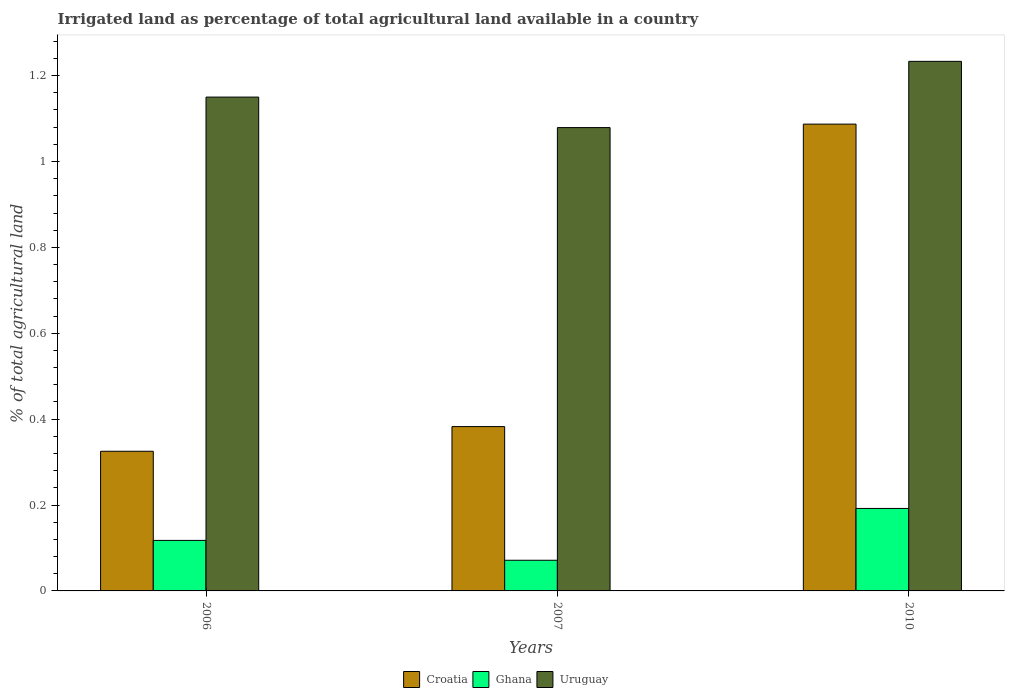How many groups of bars are there?
Offer a terse response. 3. Are the number of bars on each tick of the X-axis equal?
Offer a terse response. Yes. How many bars are there on the 3rd tick from the left?
Provide a succinct answer. 3. How many bars are there on the 2nd tick from the right?
Provide a succinct answer. 3. In how many cases, is the number of bars for a given year not equal to the number of legend labels?
Provide a short and direct response. 0. What is the percentage of irrigated land in Uruguay in 2006?
Provide a succinct answer. 1.15. Across all years, what is the maximum percentage of irrigated land in Croatia?
Your answer should be very brief. 1.09. Across all years, what is the minimum percentage of irrigated land in Uruguay?
Give a very brief answer. 1.08. What is the total percentage of irrigated land in Croatia in the graph?
Give a very brief answer. 1.8. What is the difference between the percentage of irrigated land in Ghana in 2006 and that in 2010?
Offer a terse response. -0.07. What is the difference between the percentage of irrigated land in Uruguay in 2007 and the percentage of irrigated land in Croatia in 2006?
Provide a short and direct response. 0.75. What is the average percentage of irrigated land in Ghana per year?
Your answer should be compact. 0.13. In the year 2007, what is the difference between the percentage of irrigated land in Ghana and percentage of irrigated land in Uruguay?
Your response must be concise. -1.01. In how many years, is the percentage of irrigated land in Uruguay greater than 0.24000000000000002 %?
Offer a very short reply. 3. What is the ratio of the percentage of irrigated land in Croatia in 2006 to that in 2010?
Provide a succinct answer. 0.3. Is the difference between the percentage of irrigated land in Ghana in 2006 and 2010 greater than the difference between the percentage of irrigated land in Uruguay in 2006 and 2010?
Your response must be concise. Yes. What is the difference between the highest and the second highest percentage of irrigated land in Uruguay?
Offer a terse response. 0.08. What is the difference between the highest and the lowest percentage of irrigated land in Uruguay?
Your answer should be compact. 0.15. In how many years, is the percentage of irrigated land in Ghana greater than the average percentage of irrigated land in Ghana taken over all years?
Your answer should be compact. 1. What does the 3rd bar from the left in 2006 represents?
Provide a succinct answer. Uruguay. What does the 1st bar from the right in 2010 represents?
Give a very brief answer. Uruguay. How many bars are there?
Keep it short and to the point. 9. Are all the bars in the graph horizontal?
Provide a short and direct response. No. Does the graph contain any zero values?
Make the answer very short. No. Does the graph contain grids?
Your answer should be very brief. No. How many legend labels are there?
Your answer should be very brief. 3. How are the legend labels stacked?
Your response must be concise. Horizontal. What is the title of the graph?
Provide a short and direct response. Irrigated land as percentage of total agricultural land available in a country. What is the label or title of the Y-axis?
Your answer should be compact. % of total agricultural land. What is the % of total agricultural land in Croatia in 2006?
Keep it short and to the point. 0.33. What is the % of total agricultural land of Ghana in 2006?
Give a very brief answer. 0.12. What is the % of total agricultural land in Uruguay in 2006?
Your answer should be very brief. 1.15. What is the % of total agricultural land of Croatia in 2007?
Provide a succinct answer. 0.38. What is the % of total agricultural land in Ghana in 2007?
Your answer should be very brief. 0.07. What is the % of total agricultural land in Uruguay in 2007?
Your answer should be compact. 1.08. What is the % of total agricultural land of Croatia in 2010?
Your response must be concise. 1.09. What is the % of total agricultural land in Ghana in 2010?
Ensure brevity in your answer.  0.19. What is the % of total agricultural land of Uruguay in 2010?
Your answer should be compact. 1.23. Across all years, what is the maximum % of total agricultural land of Croatia?
Provide a succinct answer. 1.09. Across all years, what is the maximum % of total agricultural land of Ghana?
Offer a terse response. 0.19. Across all years, what is the maximum % of total agricultural land of Uruguay?
Keep it short and to the point. 1.23. Across all years, what is the minimum % of total agricultural land in Croatia?
Offer a terse response. 0.33. Across all years, what is the minimum % of total agricultural land of Ghana?
Provide a short and direct response. 0.07. Across all years, what is the minimum % of total agricultural land in Uruguay?
Offer a terse response. 1.08. What is the total % of total agricultural land in Croatia in the graph?
Provide a short and direct response. 1.79. What is the total % of total agricultural land in Ghana in the graph?
Keep it short and to the point. 0.38. What is the total % of total agricultural land in Uruguay in the graph?
Keep it short and to the point. 3.46. What is the difference between the % of total agricultural land in Croatia in 2006 and that in 2007?
Your response must be concise. -0.06. What is the difference between the % of total agricultural land in Ghana in 2006 and that in 2007?
Keep it short and to the point. 0.05. What is the difference between the % of total agricultural land of Uruguay in 2006 and that in 2007?
Your answer should be very brief. 0.07. What is the difference between the % of total agricultural land of Croatia in 2006 and that in 2010?
Ensure brevity in your answer.  -0.76. What is the difference between the % of total agricultural land in Ghana in 2006 and that in 2010?
Your answer should be very brief. -0.07. What is the difference between the % of total agricultural land in Uruguay in 2006 and that in 2010?
Ensure brevity in your answer.  -0.08. What is the difference between the % of total agricultural land in Croatia in 2007 and that in 2010?
Offer a very short reply. -0.7. What is the difference between the % of total agricultural land in Ghana in 2007 and that in 2010?
Ensure brevity in your answer.  -0.12. What is the difference between the % of total agricultural land in Uruguay in 2007 and that in 2010?
Offer a terse response. -0.15. What is the difference between the % of total agricultural land of Croatia in 2006 and the % of total agricultural land of Ghana in 2007?
Provide a short and direct response. 0.25. What is the difference between the % of total agricultural land in Croatia in 2006 and the % of total agricultural land in Uruguay in 2007?
Offer a terse response. -0.75. What is the difference between the % of total agricultural land in Ghana in 2006 and the % of total agricultural land in Uruguay in 2007?
Make the answer very short. -0.96. What is the difference between the % of total agricultural land of Croatia in 2006 and the % of total agricultural land of Ghana in 2010?
Provide a short and direct response. 0.13. What is the difference between the % of total agricultural land of Croatia in 2006 and the % of total agricultural land of Uruguay in 2010?
Keep it short and to the point. -0.91. What is the difference between the % of total agricultural land of Ghana in 2006 and the % of total agricultural land of Uruguay in 2010?
Keep it short and to the point. -1.12. What is the difference between the % of total agricultural land in Croatia in 2007 and the % of total agricultural land in Ghana in 2010?
Your response must be concise. 0.19. What is the difference between the % of total agricultural land of Croatia in 2007 and the % of total agricultural land of Uruguay in 2010?
Ensure brevity in your answer.  -0.85. What is the difference between the % of total agricultural land of Ghana in 2007 and the % of total agricultural land of Uruguay in 2010?
Offer a terse response. -1.16. What is the average % of total agricultural land in Croatia per year?
Provide a succinct answer. 0.6. What is the average % of total agricultural land in Ghana per year?
Provide a succinct answer. 0.13. What is the average % of total agricultural land of Uruguay per year?
Provide a succinct answer. 1.15. In the year 2006, what is the difference between the % of total agricultural land of Croatia and % of total agricultural land of Ghana?
Ensure brevity in your answer.  0.21. In the year 2006, what is the difference between the % of total agricultural land of Croatia and % of total agricultural land of Uruguay?
Ensure brevity in your answer.  -0.82. In the year 2006, what is the difference between the % of total agricultural land in Ghana and % of total agricultural land in Uruguay?
Make the answer very short. -1.03. In the year 2007, what is the difference between the % of total agricultural land in Croatia and % of total agricultural land in Ghana?
Ensure brevity in your answer.  0.31. In the year 2007, what is the difference between the % of total agricultural land of Croatia and % of total agricultural land of Uruguay?
Give a very brief answer. -0.7. In the year 2007, what is the difference between the % of total agricultural land in Ghana and % of total agricultural land in Uruguay?
Keep it short and to the point. -1.01. In the year 2010, what is the difference between the % of total agricultural land of Croatia and % of total agricultural land of Ghana?
Offer a terse response. 0.9. In the year 2010, what is the difference between the % of total agricultural land in Croatia and % of total agricultural land in Uruguay?
Ensure brevity in your answer.  -0.15. In the year 2010, what is the difference between the % of total agricultural land in Ghana and % of total agricultural land in Uruguay?
Provide a short and direct response. -1.04. What is the ratio of the % of total agricultural land of Croatia in 2006 to that in 2007?
Provide a succinct answer. 0.85. What is the ratio of the % of total agricultural land in Ghana in 2006 to that in 2007?
Offer a very short reply. 1.65. What is the ratio of the % of total agricultural land of Uruguay in 2006 to that in 2007?
Offer a terse response. 1.07. What is the ratio of the % of total agricultural land in Croatia in 2006 to that in 2010?
Ensure brevity in your answer.  0.3. What is the ratio of the % of total agricultural land of Ghana in 2006 to that in 2010?
Your response must be concise. 0.61. What is the ratio of the % of total agricultural land in Uruguay in 2006 to that in 2010?
Your response must be concise. 0.93. What is the ratio of the % of total agricultural land of Croatia in 2007 to that in 2010?
Offer a terse response. 0.35. What is the ratio of the % of total agricultural land of Ghana in 2007 to that in 2010?
Offer a terse response. 0.37. What is the ratio of the % of total agricultural land of Uruguay in 2007 to that in 2010?
Ensure brevity in your answer.  0.87. What is the difference between the highest and the second highest % of total agricultural land in Croatia?
Give a very brief answer. 0.7. What is the difference between the highest and the second highest % of total agricultural land of Ghana?
Your answer should be very brief. 0.07. What is the difference between the highest and the second highest % of total agricultural land of Uruguay?
Make the answer very short. 0.08. What is the difference between the highest and the lowest % of total agricultural land in Croatia?
Make the answer very short. 0.76. What is the difference between the highest and the lowest % of total agricultural land in Ghana?
Your answer should be compact. 0.12. What is the difference between the highest and the lowest % of total agricultural land of Uruguay?
Your response must be concise. 0.15. 